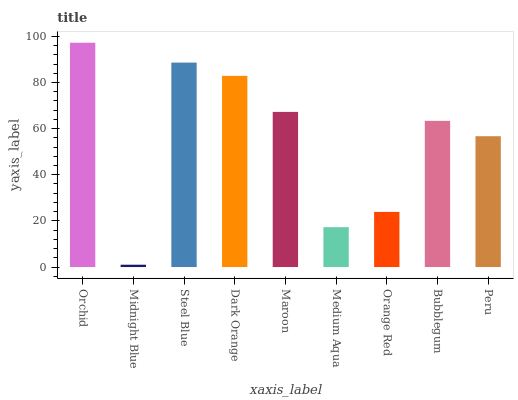Is Midnight Blue the minimum?
Answer yes or no. Yes. Is Orchid the maximum?
Answer yes or no. Yes. Is Steel Blue the minimum?
Answer yes or no. No. Is Steel Blue the maximum?
Answer yes or no. No. Is Steel Blue greater than Midnight Blue?
Answer yes or no. Yes. Is Midnight Blue less than Steel Blue?
Answer yes or no. Yes. Is Midnight Blue greater than Steel Blue?
Answer yes or no. No. Is Steel Blue less than Midnight Blue?
Answer yes or no. No. Is Bubblegum the high median?
Answer yes or no. Yes. Is Bubblegum the low median?
Answer yes or no. Yes. Is Orange Red the high median?
Answer yes or no. No. Is Maroon the low median?
Answer yes or no. No. 